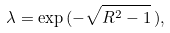<formula> <loc_0><loc_0><loc_500><loc_500>\lambda = \exp \, ( - \sqrt { R ^ { 2 } - 1 } \, ) ,</formula> 